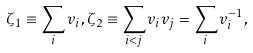Convert formula to latex. <formula><loc_0><loc_0><loc_500><loc_500>\zeta _ { 1 } \equiv \sum _ { i } v _ { i } , \zeta _ { 2 } \equiv \sum _ { i < j } v _ { i } v _ { j } = \sum _ { i } v _ { i } ^ { - 1 } ,</formula> 